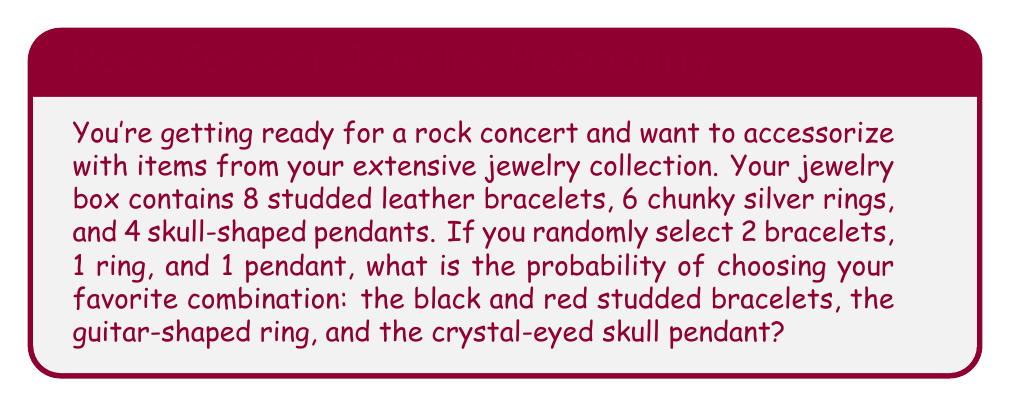Could you help me with this problem? Let's break this down step-by-step:

1) First, we need to calculate the total number of possible combinations:
   - For bracelets: We're choosing 2 out of 8, so we use the combination formula:
     $$\binom{8}{2} = \frac{8!}{2!(8-2)!} = \frac{8 \cdot 7}{2 \cdot 1} = 28$$
   - For rings: We're choosing 1 out of 6, so there are 6 possibilities.
   - For pendants: We're choosing 1 out of 4, so there are 4 possibilities.

2) The total number of possible combinations is:
   $$28 \cdot 6 \cdot 4 = 672$$

3) Now, for the specific favorite combination:
   - There's only 1 way to choose the specific black and red studded bracelets.
   - There's only 1 way to choose the specific guitar-shaped ring.
   - There's only 1 way to choose the specific crystal-eyed skull pendant.

4) So there's only 1 way to choose this exact combination out of 672 possible combinations.

5) The probability is therefore:
   $$P(\text{favorite combination}) = \frac{1}{672}$$
Answer: $\frac{1}{672}$ or approximately $0.00149$ 